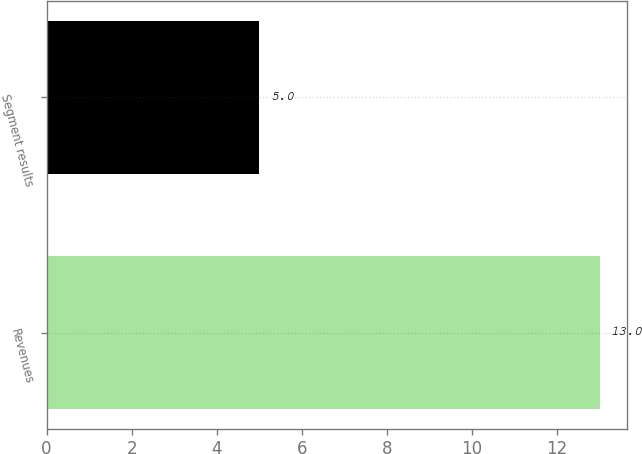Convert chart to OTSL. <chart><loc_0><loc_0><loc_500><loc_500><bar_chart><fcel>Revenues<fcel>Segment results<nl><fcel>13<fcel>5<nl></chart> 